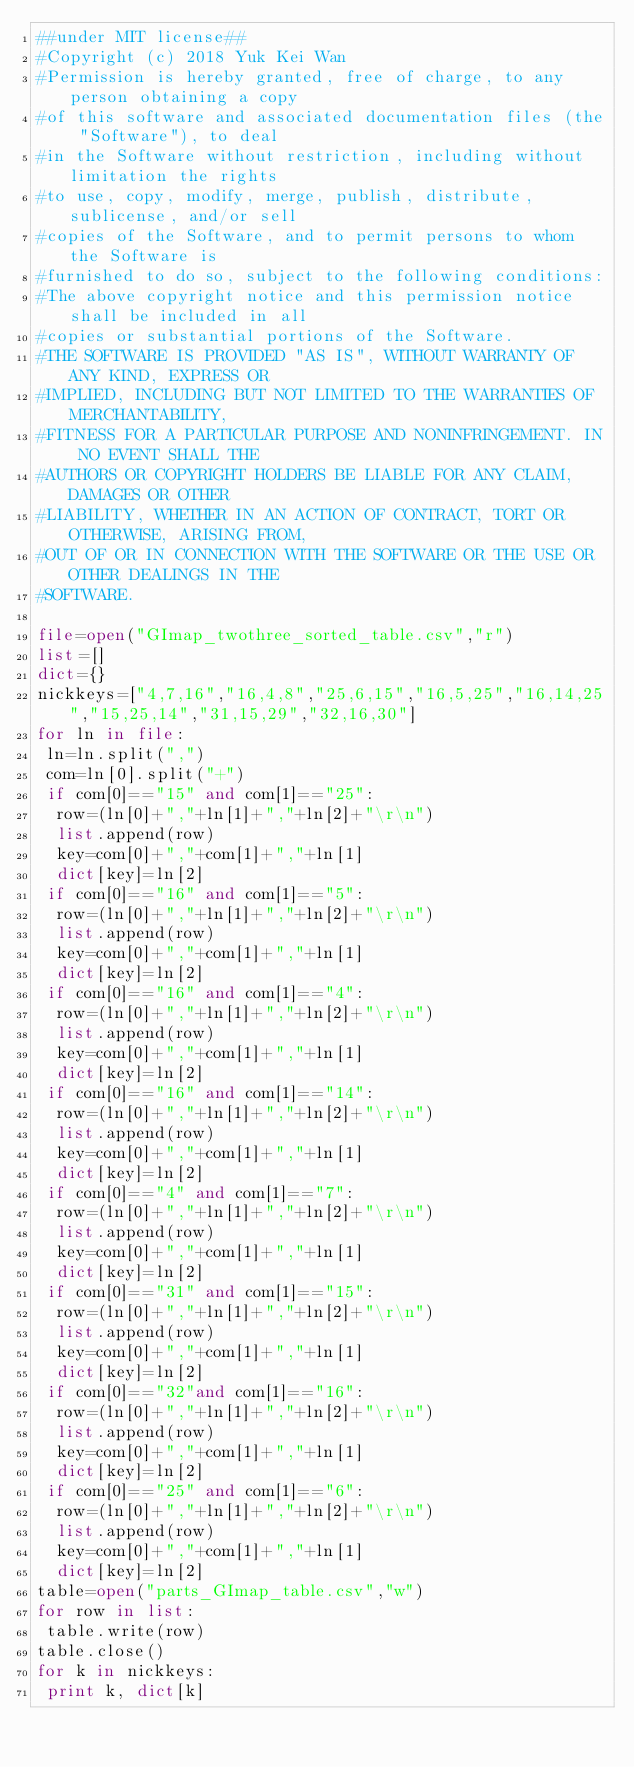<code> <loc_0><loc_0><loc_500><loc_500><_Python_>##under MIT license## 
#Copyright (c) 2018 Yuk Kei Wan
#Permission is hereby granted, free of charge, to any person obtaining a copy
#of this software and associated documentation files (the "Software"), to deal
#in the Software without restriction, including without limitation the rights
#to use, copy, modify, merge, publish, distribute, sublicense, and/or sell
#copies of the Software, and to permit persons to whom the Software is
#furnished to do so, subject to the following conditions:
#The above copyright notice and this permission notice shall be included in all
#copies or substantial portions of the Software.
#THE SOFTWARE IS PROVIDED "AS IS", WITHOUT WARRANTY OF ANY KIND, EXPRESS OR
#IMPLIED, INCLUDING BUT NOT LIMITED TO THE WARRANTIES OF MERCHANTABILITY,
#FITNESS FOR A PARTICULAR PURPOSE AND NONINFRINGEMENT. IN NO EVENT SHALL THE
#AUTHORS OR COPYRIGHT HOLDERS BE LIABLE FOR ANY CLAIM, DAMAGES OR OTHER
#LIABILITY, WHETHER IN AN ACTION OF CONTRACT, TORT OR OTHERWISE, ARISING FROM,
#OUT OF OR IN CONNECTION WITH THE SOFTWARE OR THE USE OR OTHER DEALINGS IN THE
#SOFTWARE.

file=open("GImap_twothree_sorted_table.csv","r")
list=[]
dict={}
nickkeys=["4,7,16","16,4,8","25,6,15","16,5,25","16,14,25","15,25,14","31,15,29","32,16,30"]
for ln in file:
 ln=ln.split(",")
 com=ln[0].split("+")
 if com[0]=="15" and com[1]=="25":
  row=(ln[0]+","+ln[1]+","+ln[2]+"\r\n")
  list.append(row)
  key=com[0]+","+com[1]+","+ln[1]
  dict[key]=ln[2]
 if com[0]=="16" and com[1]=="5":
  row=(ln[0]+","+ln[1]+","+ln[2]+"\r\n")
  list.append(row)
  key=com[0]+","+com[1]+","+ln[1]
  dict[key]=ln[2]
 if com[0]=="16" and com[1]=="4":
  row=(ln[0]+","+ln[1]+","+ln[2]+"\r\n")
  list.append(row)
  key=com[0]+","+com[1]+","+ln[1]
  dict[key]=ln[2]
 if com[0]=="16" and com[1]=="14":
  row=(ln[0]+","+ln[1]+","+ln[2]+"\r\n")
  list.append(row)
  key=com[0]+","+com[1]+","+ln[1]
  dict[key]=ln[2]
 if com[0]=="4" and com[1]=="7":
  row=(ln[0]+","+ln[1]+","+ln[2]+"\r\n")
  list.append(row)
  key=com[0]+","+com[1]+","+ln[1]
  dict[key]=ln[2]
 if com[0]=="31" and com[1]=="15":
  row=(ln[0]+","+ln[1]+","+ln[2]+"\r\n")
  list.append(row)
  key=com[0]+","+com[1]+","+ln[1]
  dict[key]=ln[2]
 if com[0]=="32"and com[1]=="16":
  row=(ln[0]+","+ln[1]+","+ln[2]+"\r\n")
  list.append(row)
  key=com[0]+","+com[1]+","+ln[1]
  dict[key]=ln[2]
 if com[0]=="25" and com[1]=="6":
  row=(ln[0]+","+ln[1]+","+ln[2]+"\r\n")
  list.append(row)
  key=com[0]+","+com[1]+","+ln[1]
  dict[key]=ln[2]
table=open("parts_GImap_table.csv","w")
for row in list:
 table.write(row)
table.close()
for k in nickkeys:
 print k, dict[k]
  
</code> 